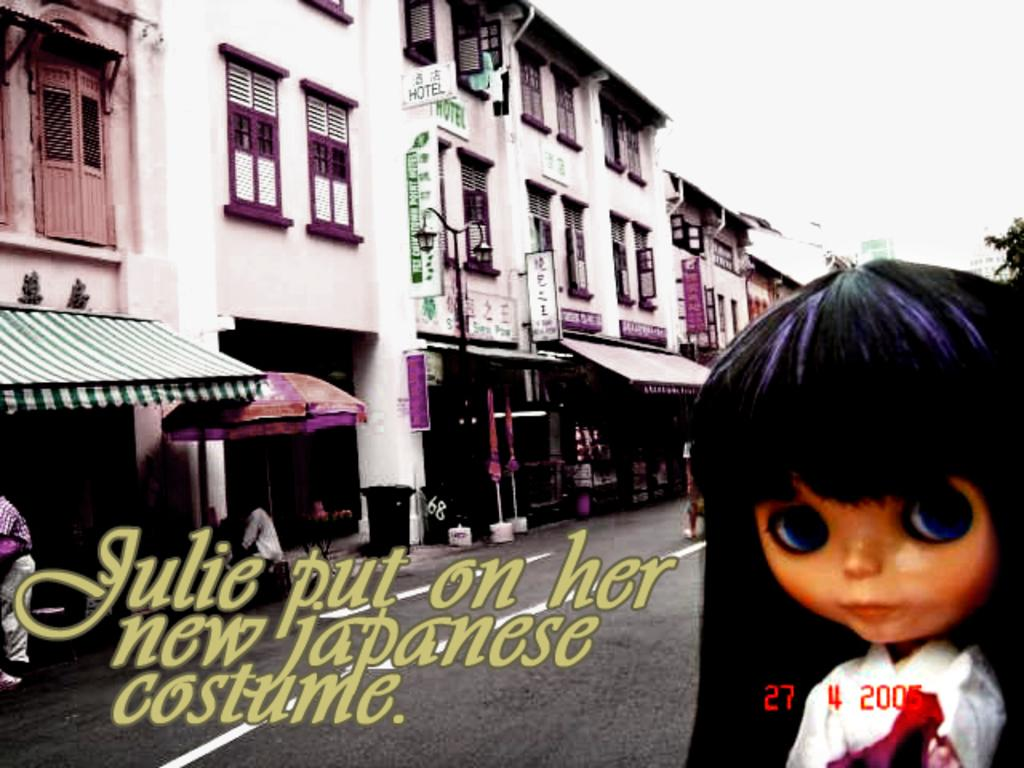What can be seen in the left corner of the image? There are buildings in the left corner of the image. What is located in the right corner of the image? There is a doll in the right corner of the image. What is written beside the doll? There is something written beside the doll. What is the income of the doll in the image? There is no information about the doll's income in the image, as dolls do not have income. 